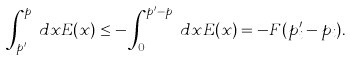Convert formula to latex. <formula><loc_0><loc_0><loc_500><loc_500>\int _ { p _ { i } ^ { \prime } } ^ { p _ { i } } d x E ( x ) \leq - \int _ { 0 } ^ { p _ { i } ^ { \prime } - p _ { i } } d x E ( x ) = - F ( p _ { i } ^ { \prime } - p _ { i } ) .</formula> 